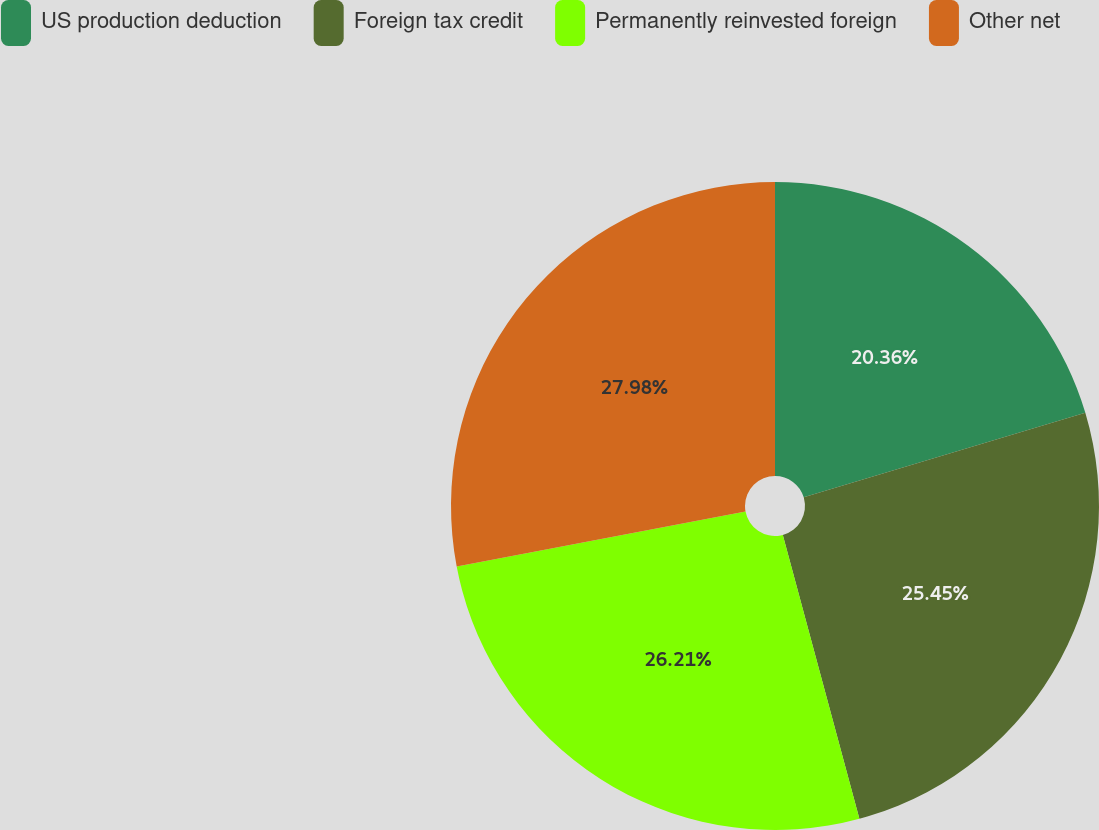Convert chart to OTSL. <chart><loc_0><loc_0><loc_500><loc_500><pie_chart><fcel>US production deduction<fcel>Foreign tax credit<fcel>Permanently reinvested foreign<fcel>Other net<nl><fcel>20.36%<fcel>25.45%<fcel>26.21%<fcel>27.99%<nl></chart> 